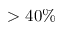Convert formula to latex. <formula><loc_0><loc_0><loc_500><loc_500>> 4 0 \%</formula> 